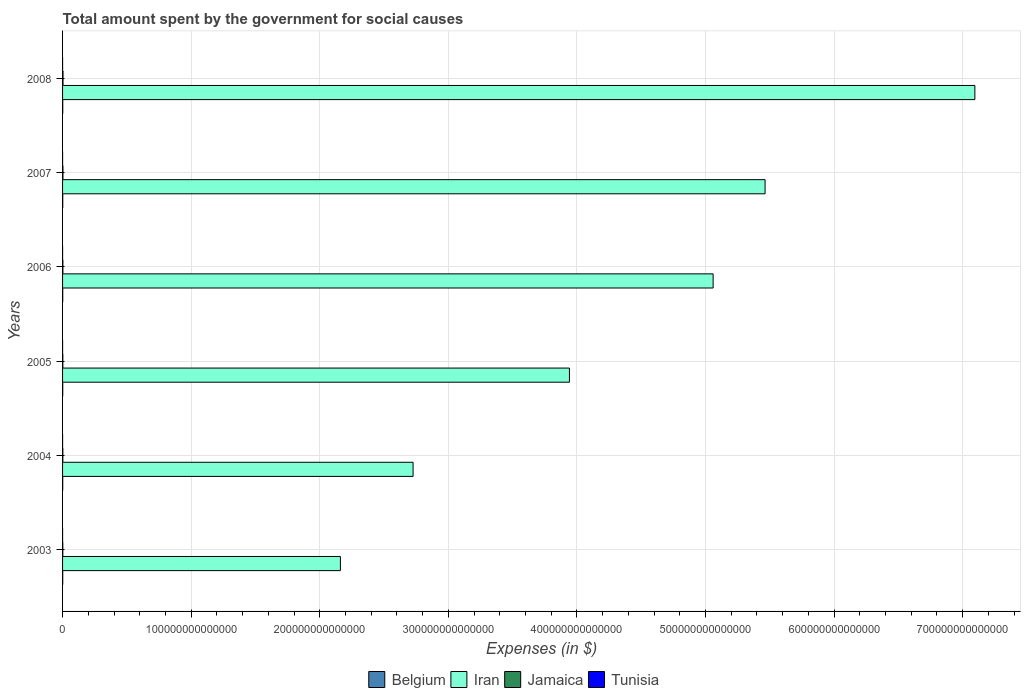How many different coloured bars are there?
Offer a very short reply. 4. How many groups of bars are there?
Your response must be concise. 6. Are the number of bars per tick equal to the number of legend labels?
Ensure brevity in your answer.  Yes. How many bars are there on the 1st tick from the top?
Ensure brevity in your answer.  4. How many bars are there on the 6th tick from the bottom?
Your response must be concise. 4. What is the label of the 6th group of bars from the top?
Offer a very short reply. 2003. What is the amount spent for social causes by the government in Belgium in 2004?
Make the answer very short. 1.21e+11. Across all years, what is the maximum amount spent for social causes by the government in Iran?
Give a very brief answer. 7.10e+14. Across all years, what is the minimum amount spent for social causes by the government in Tunisia?
Ensure brevity in your answer.  8.97e+09. In which year was the amount spent for social causes by the government in Jamaica maximum?
Your answer should be compact. 2008. What is the total amount spent for social causes by the government in Belgium in the graph?
Keep it short and to the point. 7.91e+11. What is the difference between the amount spent for social causes by the government in Tunisia in 2004 and that in 2006?
Give a very brief answer. -1.82e+09. What is the difference between the amount spent for social causes by the government in Jamaica in 2006 and the amount spent for social causes by the government in Tunisia in 2003?
Offer a very short reply. 2.46e+11. What is the average amount spent for social causes by the government in Belgium per year?
Make the answer very short. 1.32e+11. In the year 2004, what is the difference between the amount spent for social causes by the government in Belgium and amount spent for social causes by the government in Jamaica?
Make the answer very short. -9.24e+1. What is the ratio of the amount spent for social causes by the government in Iran in 2004 to that in 2006?
Your response must be concise. 0.54. What is the difference between the highest and the second highest amount spent for social causes by the government in Iran?
Your answer should be compact. 1.63e+14. What is the difference between the highest and the lowest amount spent for social causes by the government in Belgium?
Your answer should be compact. 2.75e+1. What does the 1st bar from the top in 2006 represents?
Your answer should be very brief. Tunisia. What does the 2nd bar from the bottom in 2006 represents?
Provide a short and direct response. Iran. What is the difference between two consecutive major ticks on the X-axis?
Provide a short and direct response. 1.00e+14. Does the graph contain any zero values?
Make the answer very short. No. Does the graph contain grids?
Ensure brevity in your answer.  Yes. What is the title of the graph?
Offer a very short reply. Total amount spent by the government for social causes. Does "Middle East & North Africa (all income levels)" appear as one of the legend labels in the graph?
Your answer should be compact. No. What is the label or title of the X-axis?
Your answer should be very brief. Expenses (in $). What is the label or title of the Y-axis?
Make the answer very short. Years. What is the Expenses (in $) of Belgium in 2003?
Your answer should be compact. 1.19e+11. What is the Expenses (in $) of Iran in 2003?
Provide a succinct answer. 2.16e+14. What is the Expenses (in $) in Jamaica in 2003?
Give a very brief answer. 1.87e+11. What is the Expenses (in $) in Tunisia in 2003?
Your answer should be very brief. 8.97e+09. What is the Expenses (in $) in Belgium in 2004?
Provide a short and direct response. 1.21e+11. What is the Expenses (in $) of Iran in 2004?
Keep it short and to the point. 2.73e+14. What is the Expenses (in $) of Jamaica in 2004?
Offer a terse response. 2.14e+11. What is the Expenses (in $) in Tunisia in 2004?
Make the answer very short. 1.00e+1. What is the Expenses (in $) of Belgium in 2005?
Your answer should be compact. 1.35e+11. What is the Expenses (in $) in Iran in 2005?
Give a very brief answer. 3.94e+14. What is the Expenses (in $) in Jamaica in 2005?
Provide a succinct answer. 2.15e+11. What is the Expenses (in $) of Tunisia in 2005?
Keep it short and to the point. 1.09e+1. What is the Expenses (in $) of Belgium in 2006?
Provide a short and direct response. 1.31e+11. What is the Expenses (in $) of Iran in 2006?
Make the answer very short. 5.06e+14. What is the Expenses (in $) of Jamaica in 2006?
Your answer should be very brief. 2.55e+11. What is the Expenses (in $) of Tunisia in 2006?
Your answer should be very brief. 1.18e+1. What is the Expenses (in $) in Belgium in 2007?
Ensure brevity in your answer.  1.38e+11. What is the Expenses (in $) in Iran in 2007?
Give a very brief answer. 5.46e+14. What is the Expenses (in $) of Jamaica in 2007?
Your response must be concise. 3.03e+11. What is the Expenses (in $) of Tunisia in 2007?
Provide a short and direct response. 1.31e+1. What is the Expenses (in $) of Belgium in 2008?
Provide a short and direct response. 1.47e+11. What is the Expenses (in $) in Iran in 2008?
Make the answer very short. 7.10e+14. What is the Expenses (in $) of Jamaica in 2008?
Make the answer very short. 3.55e+11. What is the Expenses (in $) of Tunisia in 2008?
Provide a short and direct response. 1.51e+1. Across all years, what is the maximum Expenses (in $) of Belgium?
Offer a terse response. 1.47e+11. Across all years, what is the maximum Expenses (in $) in Iran?
Make the answer very short. 7.10e+14. Across all years, what is the maximum Expenses (in $) of Jamaica?
Your answer should be compact. 3.55e+11. Across all years, what is the maximum Expenses (in $) of Tunisia?
Ensure brevity in your answer.  1.51e+1. Across all years, what is the minimum Expenses (in $) in Belgium?
Ensure brevity in your answer.  1.19e+11. Across all years, what is the minimum Expenses (in $) in Iran?
Your answer should be very brief. 2.16e+14. Across all years, what is the minimum Expenses (in $) of Jamaica?
Provide a short and direct response. 1.87e+11. Across all years, what is the minimum Expenses (in $) of Tunisia?
Make the answer very short. 8.97e+09. What is the total Expenses (in $) of Belgium in the graph?
Provide a short and direct response. 7.91e+11. What is the total Expenses (in $) of Iran in the graph?
Give a very brief answer. 2.64e+15. What is the total Expenses (in $) of Jamaica in the graph?
Your answer should be very brief. 1.53e+12. What is the total Expenses (in $) in Tunisia in the graph?
Your answer should be compact. 6.99e+1. What is the difference between the Expenses (in $) of Belgium in 2003 and that in 2004?
Keep it short and to the point. -1.83e+09. What is the difference between the Expenses (in $) in Iran in 2003 and that in 2004?
Your response must be concise. -5.65e+13. What is the difference between the Expenses (in $) of Jamaica in 2003 and that in 2004?
Your answer should be very brief. -2.65e+1. What is the difference between the Expenses (in $) in Tunisia in 2003 and that in 2004?
Make the answer very short. -1.04e+09. What is the difference between the Expenses (in $) in Belgium in 2003 and that in 2005?
Make the answer very short. -1.54e+1. What is the difference between the Expenses (in $) in Iran in 2003 and that in 2005?
Provide a short and direct response. -1.78e+14. What is the difference between the Expenses (in $) of Jamaica in 2003 and that in 2005?
Give a very brief answer. -2.84e+1. What is the difference between the Expenses (in $) of Tunisia in 2003 and that in 2005?
Your response must be concise. -1.98e+09. What is the difference between the Expenses (in $) of Belgium in 2003 and that in 2006?
Your response must be concise. -1.18e+1. What is the difference between the Expenses (in $) of Iran in 2003 and that in 2006?
Offer a very short reply. -2.90e+14. What is the difference between the Expenses (in $) of Jamaica in 2003 and that in 2006?
Keep it short and to the point. -6.77e+1. What is the difference between the Expenses (in $) in Tunisia in 2003 and that in 2006?
Your answer should be very brief. -2.85e+09. What is the difference between the Expenses (in $) of Belgium in 2003 and that in 2007?
Provide a short and direct response. -1.82e+1. What is the difference between the Expenses (in $) of Iran in 2003 and that in 2007?
Give a very brief answer. -3.30e+14. What is the difference between the Expenses (in $) in Jamaica in 2003 and that in 2007?
Provide a succinct answer. -1.16e+11. What is the difference between the Expenses (in $) in Tunisia in 2003 and that in 2007?
Provide a short and direct response. -4.08e+09. What is the difference between the Expenses (in $) of Belgium in 2003 and that in 2008?
Your answer should be compact. -2.75e+1. What is the difference between the Expenses (in $) in Iran in 2003 and that in 2008?
Offer a very short reply. -4.93e+14. What is the difference between the Expenses (in $) of Jamaica in 2003 and that in 2008?
Your answer should be compact. -1.68e+11. What is the difference between the Expenses (in $) in Tunisia in 2003 and that in 2008?
Give a very brief answer. -6.13e+09. What is the difference between the Expenses (in $) of Belgium in 2004 and that in 2005?
Keep it short and to the point. -1.36e+1. What is the difference between the Expenses (in $) of Iran in 2004 and that in 2005?
Offer a terse response. -1.22e+14. What is the difference between the Expenses (in $) of Jamaica in 2004 and that in 2005?
Make the answer very short. -1.88e+09. What is the difference between the Expenses (in $) in Tunisia in 2004 and that in 2005?
Provide a succinct answer. -9.39e+08. What is the difference between the Expenses (in $) of Belgium in 2004 and that in 2006?
Offer a very short reply. -9.96e+09. What is the difference between the Expenses (in $) in Iran in 2004 and that in 2006?
Ensure brevity in your answer.  -2.33e+14. What is the difference between the Expenses (in $) in Jamaica in 2004 and that in 2006?
Your answer should be compact. -4.11e+1. What is the difference between the Expenses (in $) of Tunisia in 2004 and that in 2006?
Ensure brevity in your answer.  -1.82e+09. What is the difference between the Expenses (in $) of Belgium in 2004 and that in 2007?
Your answer should be compact. -1.64e+1. What is the difference between the Expenses (in $) in Iran in 2004 and that in 2007?
Your answer should be compact. -2.74e+14. What is the difference between the Expenses (in $) in Jamaica in 2004 and that in 2007?
Provide a succinct answer. -8.98e+1. What is the difference between the Expenses (in $) in Tunisia in 2004 and that in 2007?
Your answer should be compact. -3.04e+09. What is the difference between the Expenses (in $) of Belgium in 2004 and that in 2008?
Provide a short and direct response. -2.57e+1. What is the difference between the Expenses (in $) of Iran in 2004 and that in 2008?
Give a very brief answer. -4.37e+14. What is the difference between the Expenses (in $) of Jamaica in 2004 and that in 2008?
Your response must be concise. -1.42e+11. What is the difference between the Expenses (in $) of Tunisia in 2004 and that in 2008?
Your answer should be compact. -5.09e+09. What is the difference between the Expenses (in $) of Belgium in 2005 and that in 2006?
Provide a succinct answer. 3.59e+09. What is the difference between the Expenses (in $) in Iran in 2005 and that in 2006?
Your answer should be very brief. -1.12e+14. What is the difference between the Expenses (in $) of Jamaica in 2005 and that in 2006?
Provide a short and direct response. -3.93e+1. What is the difference between the Expenses (in $) in Tunisia in 2005 and that in 2006?
Ensure brevity in your answer.  -8.79e+08. What is the difference between the Expenses (in $) in Belgium in 2005 and that in 2007?
Make the answer very short. -2.83e+09. What is the difference between the Expenses (in $) of Iran in 2005 and that in 2007?
Offer a terse response. -1.52e+14. What is the difference between the Expenses (in $) in Jamaica in 2005 and that in 2007?
Ensure brevity in your answer.  -8.79e+1. What is the difference between the Expenses (in $) of Tunisia in 2005 and that in 2007?
Your answer should be compact. -2.10e+09. What is the difference between the Expenses (in $) in Belgium in 2005 and that in 2008?
Provide a succinct answer. -1.21e+1. What is the difference between the Expenses (in $) in Iran in 2005 and that in 2008?
Your answer should be compact. -3.15e+14. What is the difference between the Expenses (in $) in Jamaica in 2005 and that in 2008?
Ensure brevity in your answer.  -1.40e+11. What is the difference between the Expenses (in $) of Tunisia in 2005 and that in 2008?
Ensure brevity in your answer.  -4.15e+09. What is the difference between the Expenses (in $) in Belgium in 2006 and that in 2007?
Give a very brief answer. -6.42e+09. What is the difference between the Expenses (in $) in Iran in 2006 and that in 2007?
Keep it short and to the point. -4.04e+13. What is the difference between the Expenses (in $) in Jamaica in 2006 and that in 2007?
Your answer should be very brief. -4.86e+1. What is the difference between the Expenses (in $) in Tunisia in 2006 and that in 2007?
Offer a terse response. -1.22e+09. What is the difference between the Expenses (in $) in Belgium in 2006 and that in 2008?
Give a very brief answer. -1.57e+1. What is the difference between the Expenses (in $) in Iran in 2006 and that in 2008?
Make the answer very short. -2.04e+14. What is the difference between the Expenses (in $) of Jamaica in 2006 and that in 2008?
Offer a very short reply. -1.01e+11. What is the difference between the Expenses (in $) of Tunisia in 2006 and that in 2008?
Make the answer very short. -3.27e+09. What is the difference between the Expenses (in $) in Belgium in 2007 and that in 2008?
Offer a very short reply. -9.32e+09. What is the difference between the Expenses (in $) of Iran in 2007 and that in 2008?
Provide a succinct answer. -1.63e+14. What is the difference between the Expenses (in $) in Jamaica in 2007 and that in 2008?
Provide a short and direct response. -5.21e+1. What is the difference between the Expenses (in $) in Tunisia in 2007 and that in 2008?
Your response must be concise. -2.05e+09. What is the difference between the Expenses (in $) of Belgium in 2003 and the Expenses (in $) of Iran in 2004?
Your response must be concise. -2.72e+14. What is the difference between the Expenses (in $) of Belgium in 2003 and the Expenses (in $) of Jamaica in 2004?
Give a very brief answer. -9.42e+1. What is the difference between the Expenses (in $) of Belgium in 2003 and the Expenses (in $) of Tunisia in 2004?
Make the answer very short. 1.09e+11. What is the difference between the Expenses (in $) in Iran in 2003 and the Expenses (in $) in Jamaica in 2004?
Your response must be concise. 2.16e+14. What is the difference between the Expenses (in $) of Iran in 2003 and the Expenses (in $) of Tunisia in 2004?
Give a very brief answer. 2.16e+14. What is the difference between the Expenses (in $) of Jamaica in 2003 and the Expenses (in $) of Tunisia in 2004?
Your answer should be very brief. 1.77e+11. What is the difference between the Expenses (in $) of Belgium in 2003 and the Expenses (in $) of Iran in 2005?
Your answer should be compact. -3.94e+14. What is the difference between the Expenses (in $) in Belgium in 2003 and the Expenses (in $) in Jamaica in 2005?
Offer a very short reply. -9.61e+1. What is the difference between the Expenses (in $) in Belgium in 2003 and the Expenses (in $) in Tunisia in 2005?
Offer a very short reply. 1.08e+11. What is the difference between the Expenses (in $) in Iran in 2003 and the Expenses (in $) in Jamaica in 2005?
Provide a succinct answer. 2.16e+14. What is the difference between the Expenses (in $) in Iran in 2003 and the Expenses (in $) in Tunisia in 2005?
Provide a succinct answer. 2.16e+14. What is the difference between the Expenses (in $) in Jamaica in 2003 and the Expenses (in $) in Tunisia in 2005?
Make the answer very short. 1.76e+11. What is the difference between the Expenses (in $) of Belgium in 2003 and the Expenses (in $) of Iran in 2006?
Offer a terse response. -5.06e+14. What is the difference between the Expenses (in $) of Belgium in 2003 and the Expenses (in $) of Jamaica in 2006?
Provide a succinct answer. -1.35e+11. What is the difference between the Expenses (in $) in Belgium in 2003 and the Expenses (in $) in Tunisia in 2006?
Ensure brevity in your answer.  1.07e+11. What is the difference between the Expenses (in $) of Iran in 2003 and the Expenses (in $) of Jamaica in 2006?
Offer a terse response. 2.16e+14. What is the difference between the Expenses (in $) of Iran in 2003 and the Expenses (in $) of Tunisia in 2006?
Offer a very short reply. 2.16e+14. What is the difference between the Expenses (in $) of Jamaica in 2003 and the Expenses (in $) of Tunisia in 2006?
Make the answer very short. 1.75e+11. What is the difference between the Expenses (in $) of Belgium in 2003 and the Expenses (in $) of Iran in 2007?
Offer a very short reply. -5.46e+14. What is the difference between the Expenses (in $) of Belgium in 2003 and the Expenses (in $) of Jamaica in 2007?
Give a very brief answer. -1.84e+11. What is the difference between the Expenses (in $) in Belgium in 2003 and the Expenses (in $) in Tunisia in 2007?
Ensure brevity in your answer.  1.06e+11. What is the difference between the Expenses (in $) in Iran in 2003 and the Expenses (in $) in Jamaica in 2007?
Make the answer very short. 2.16e+14. What is the difference between the Expenses (in $) of Iran in 2003 and the Expenses (in $) of Tunisia in 2007?
Make the answer very short. 2.16e+14. What is the difference between the Expenses (in $) of Jamaica in 2003 and the Expenses (in $) of Tunisia in 2007?
Your answer should be very brief. 1.74e+11. What is the difference between the Expenses (in $) in Belgium in 2003 and the Expenses (in $) in Iran in 2008?
Your response must be concise. -7.09e+14. What is the difference between the Expenses (in $) of Belgium in 2003 and the Expenses (in $) of Jamaica in 2008?
Offer a very short reply. -2.36e+11. What is the difference between the Expenses (in $) of Belgium in 2003 and the Expenses (in $) of Tunisia in 2008?
Provide a succinct answer. 1.04e+11. What is the difference between the Expenses (in $) in Iran in 2003 and the Expenses (in $) in Jamaica in 2008?
Your answer should be compact. 2.16e+14. What is the difference between the Expenses (in $) of Iran in 2003 and the Expenses (in $) of Tunisia in 2008?
Make the answer very short. 2.16e+14. What is the difference between the Expenses (in $) in Jamaica in 2003 and the Expenses (in $) in Tunisia in 2008?
Your response must be concise. 1.72e+11. What is the difference between the Expenses (in $) in Belgium in 2004 and the Expenses (in $) in Iran in 2005?
Offer a very short reply. -3.94e+14. What is the difference between the Expenses (in $) in Belgium in 2004 and the Expenses (in $) in Jamaica in 2005?
Make the answer very short. -9.43e+1. What is the difference between the Expenses (in $) of Belgium in 2004 and the Expenses (in $) of Tunisia in 2005?
Your answer should be compact. 1.10e+11. What is the difference between the Expenses (in $) of Iran in 2004 and the Expenses (in $) of Jamaica in 2005?
Give a very brief answer. 2.72e+14. What is the difference between the Expenses (in $) in Iran in 2004 and the Expenses (in $) in Tunisia in 2005?
Make the answer very short. 2.73e+14. What is the difference between the Expenses (in $) of Jamaica in 2004 and the Expenses (in $) of Tunisia in 2005?
Keep it short and to the point. 2.03e+11. What is the difference between the Expenses (in $) in Belgium in 2004 and the Expenses (in $) in Iran in 2006?
Offer a very short reply. -5.06e+14. What is the difference between the Expenses (in $) of Belgium in 2004 and the Expenses (in $) of Jamaica in 2006?
Keep it short and to the point. -1.34e+11. What is the difference between the Expenses (in $) of Belgium in 2004 and the Expenses (in $) of Tunisia in 2006?
Ensure brevity in your answer.  1.09e+11. What is the difference between the Expenses (in $) in Iran in 2004 and the Expenses (in $) in Jamaica in 2006?
Your answer should be compact. 2.72e+14. What is the difference between the Expenses (in $) of Iran in 2004 and the Expenses (in $) of Tunisia in 2006?
Provide a short and direct response. 2.73e+14. What is the difference between the Expenses (in $) in Jamaica in 2004 and the Expenses (in $) in Tunisia in 2006?
Offer a terse response. 2.02e+11. What is the difference between the Expenses (in $) in Belgium in 2004 and the Expenses (in $) in Iran in 2007?
Keep it short and to the point. -5.46e+14. What is the difference between the Expenses (in $) in Belgium in 2004 and the Expenses (in $) in Jamaica in 2007?
Provide a succinct answer. -1.82e+11. What is the difference between the Expenses (in $) of Belgium in 2004 and the Expenses (in $) of Tunisia in 2007?
Your answer should be compact. 1.08e+11. What is the difference between the Expenses (in $) of Iran in 2004 and the Expenses (in $) of Jamaica in 2007?
Give a very brief answer. 2.72e+14. What is the difference between the Expenses (in $) in Iran in 2004 and the Expenses (in $) in Tunisia in 2007?
Ensure brevity in your answer.  2.73e+14. What is the difference between the Expenses (in $) of Jamaica in 2004 and the Expenses (in $) of Tunisia in 2007?
Keep it short and to the point. 2.00e+11. What is the difference between the Expenses (in $) of Belgium in 2004 and the Expenses (in $) of Iran in 2008?
Offer a very short reply. -7.09e+14. What is the difference between the Expenses (in $) of Belgium in 2004 and the Expenses (in $) of Jamaica in 2008?
Ensure brevity in your answer.  -2.34e+11. What is the difference between the Expenses (in $) in Belgium in 2004 and the Expenses (in $) in Tunisia in 2008?
Your answer should be compact. 1.06e+11. What is the difference between the Expenses (in $) of Iran in 2004 and the Expenses (in $) of Jamaica in 2008?
Your answer should be compact. 2.72e+14. What is the difference between the Expenses (in $) of Iran in 2004 and the Expenses (in $) of Tunisia in 2008?
Ensure brevity in your answer.  2.73e+14. What is the difference between the Expenses (in $) in Jamaica in 2004 and the Expenses (in $) in Tunisia in 2008?
Keep it short and to the point. 1.98e+11. What is the difference between the Expenses (in $) of Belgium in 2005 and the Expenses (in $) of Iran in 2006?
Your response must be concise. -5.06e+14. What is the difference between the Expenses (in $) of Belgium in 2005 and the Expenses (in $) of Jamaica in 2006?
Your answer should be compact. -1.20e+11. What is the difference between the Expenses (in $) in Belgium in 2005 and the Expenses (in $) in Tunisia in 2006?
Keep it short and to the point. 1.23e+11. What is the difference between the Expenses (in $) of Iran in 2005 and the Expenses (in $) of Jamaica in 2006?
Provide a succinct answer. 3.94e+14. What is the difference between the Expenses (in $) in Iran in 2005 and the Expenses (in $) in Tunisia in 2006?
Offer a very short reply. 3.94e+14. What is the difference between the Expenses (in $) in Jamaica in 2005 and the Expenses (in $) in Tunisia in 2006?
Your answer should be very brief. 2.04e+11. What is the difference between the Expenses (in $) of Belgium in 2005 and the Expenses (in $) of Iran in 2007?
Offer a terse response. -5.46e+14. What is the difference between the Expenses (in $) of Belgium in 2005 and the Expenses (in $) of Jamaica in 2007?
Make the answer very short. -1.69e+11. What is the difference between the Expenses (in $) in Belgium in 2005 and the Expenses (in $) in Tunisia in 2007?
Provide a short and direct response. 1.22e+11. What is the difference between the Expenses (in $) in Iran in 2005 and the Expenses (in $) in Jamaica in 2007?
Make the answer very short. 3.94e+14. What is the difference between the Expenses (in $) of Iran in 2005 and the Expenses (in $) of Tunisia in 2007?
Make the answer very short. 3.94e+14. What is the difference between the Expenses (in $) of Jamaica in 2005 and the Expenses (in $) of Tunisia in 2007?
Keep it short and to the point. 2.02e+11. What is the difference between the Expenses (in $) of Belgium in 2005 and the Expenses (in $) of Iran in 2008?
Make the answer very short. -7.09e+14. What is the difference between the Expenses (in $) in Belgium in 2005 and the Expenses (in $) in Jamaica in 2008?
Ensure brevity in your answer.  -2.21e+11. What is the difference between the Expenses (in $) of Belgium in 2005 and the Expenses (in $) of Tunisia in 2008?
Offer a terse response. 1.20e+11. What is the difference between the Expenses (in $) of Iran in 2005 and the Expenses (in $) of Jamaica in 2008?
Offer a very short reply. 3.94e+14. What is the difference between the Expenses (in $) in Iran in 2005 and the Expenses (in $) in Tunisia in 2008?
Provide a short and direct response. 3.94e+14. What is the difference between the Expenses (in $) of Jamaica in 2005 and the Expenses (in $) of Tunisia in 2008?
Your answer should be very brief. 2.00e+11. What is the difference between the Expenses (in $) in Belgium in 2006 and the Expenses (in $) in Iran in 2007?
Make the answer very short. -5.46e+14. What is the difference between the Expenses (in $) in Belgium in 2006 and the Expenses (in $) in Jamaica in 2007?
Your answer should be very brief. -1.72e+11. What is the difference between the Expenses (in $) of Belgium in 2006 and the Expenses (in $) of Tunisia in 2007?
Ensure brevity in your answer.  1.18e+11. What is the difference between the Expenses (in $) of Iran in 2006 and the Expenses (in $) of Jamaica in 2007?
Ensure brevity in your answer.  5.06e+14. What is the difference between the Expenses (in $) in Iran in 2006 and the Expenses (in $) in Tunisia in 2007?
Ensure brevity in your answer.  5.06e+14. What is the difference between the Expenses (in $) in Jamaica in 2006 and the Expenses (in $) in Tunisia in 2007?
Your answer should be very brief. 2.42e+11. What is the difference between the Expenses (in $) of Belgium in 2006 and the Expenses (in $) of Iran in 2008?
Give a very brief answer. -7.09e+14. What is the difference between the Expenses (in $) of Belgium in 2006 and the Expenses (in $) of Jamaica in 2008?
Provide a short and direct response. -2.24e+11. What is the difference between the Expenses (in $) in Belgium in 2006 and the Expenses (in $) in Tunisia in 2008?
Provide a short and direct response. 1.16e+11. What is the difference between the Expenses (in $) of Iran in 2006 and the Expenses (in $) of Jamaica in 2008?
Make the answer very short. 5.06e+14. What is the difference between the Expenses (in $) in Iran in 2006 and the Expenses (in $) in Tunisia in 2008?
Your answer should be compact. 5.06e+14. What is the difference between the Expenses (in $) of Jamaica in 2006 and the Expenses (in $) of Tunisia in 2008?
Make the answer very short. 2.40e+11. What is the difference between the Expenses (in $) in Belgium in 2007 and the Expenses (in $) in Iran in 2008?
Make the answer very short. -7.09e+14. What is the difference between the Expenses (in $) in Belgium in 2007 and the Expenses (in $) in Jamaica in 2008?
Provide a succinct answer. -2.18e+11. What is the difference between the Expenses (in $) in Belgium in 2007 and the Expenses (in $) in Tunisia in 2008?
Your response must be concise. 1.22e+11. What is the difference between the Expenses (in $) in Iran in 2007 and the Expenses (in $) in Jamaica in 2008?
Offer a very short reply. 5.46e+14. What is the difference between the Expenses (in $) of Iran in 2007 and the Expenses (in $) of Tunisia in 2008?
Offer a very short reply. 5.46e+14. What is the difference between the Expenses (in $) of Jamaica in 2007 and the Expenses (in $) of Tunisia in 2008?
Your answer should be very brief. 2.88e+11. What is the average Expenses (in $) in Belgium per year?
Your answer should be very brief. 1.32e+11. What is the average Expenses (in $) of Iran per year?
Provide a succinct answer. 4.41e+14. What is the average Expenses (in $) of Jamaica per year?
Ensure brevity in your answer.  2.55e+11. What is the average Expenses (in $) in Tunisia per year?
Offer a very short reply. 1.17e+1. In the year 2003, what is the difference between the Expenses (in $) in Belgium and Expenses (in $) in Iran?
Your response must be concise. -2.16e+14. In the year 2003, what is the difference between the Expenses (in $) of Belgium and Expenses (in $) of Jamaica?
Offer a very short reply. -6.77e+1. In the year 2003, what is the difference between the Expenses (in $) in Belgium and Expenses (in $) in Tunisia?
Provide a succinct answer. 1.10e+11. In the year 2003, what is the difference between the Expenses (in $) of Iran and Expenses (in $) of Jamaica?
Offer a terse response. 2.16e+14. In the year 2003, what is the difference between the Expenses (in $) in Iran and Expenses (in $) in Tunisia?
Make the answer very short. 2.16e+14. In the year 2003, what is the difference between the Expenses (in $) in Jamaica and Expenses (in $) in Tunisia?
Keep it short and to the point. 1.78e+11. In the year 2004, what is the difference between the Expenses (in $) in Belgium and Expenses (in $) in Iran?
Offer a terse response. -2.72e+14. In the year 2004, what is the difference between the Expenses (in $) in Belgium and Expenses (in $) in Jamaica?
Keep it short and to the point. -9.24e+1. In the year 2004, what is the difference between the Expenses (in $) in Belgium and Expenses (in $) in Tunisia?
Provide a succinct answer. 1.11e+11. In the year 2004, what is the difference between the Expenses (in $) of Iran and Expenses (in $) of Jamaica?
Keep it short and to the point. 2.72e+14. In the year 2004, what is the difference between the Expenses (in $) in Iran and Expenses (in $) in Tunisia?
Provide a succinct answer. 2.73e+14. In the year 2004, what is the difference between the Expenses (in $) of Jamaica and Expenses (in $) of Tunisia?
Offer a terse response. 2.04e+11. In the year 2005, what is the difference between the Expenses (in $) in Belgium and Expenses (in $) in Iran?
Make the answer very short. -3.94e+14. In the year 2005, what is the difference between the Expenses (in $) of Belgium and Expenses (in $) of Jamaica?
Provide a short and direct response. -8.07e+1. In the year 2005, what is the difference between the Expenses (in $) of Belgium and Expenses (in $) of Tunisia?
Provide a short and direct response. 1.24e+11. In the year 2005, what is the difference between the Expenses (in $) of Iran and Expenses (in $) of Jamaica?
Provide a succinct answer. 3.94e+14. In the year 2005, what is the difference between the Expenses (in $) of Iran and Expenses (in $) of Tunisia?
Your answer should be very brief. 3.94e+14. In the year 2005, what is the difference between the Expenses (in $) of Jamaica and Expenses (in $) of Tunisia?
Provide a succinct answer. 2.04e+11. In the year 2006, what is the difference between the Expenses (in $) of Belgium and Expenses (in $) of Iran?
Make the answer very short. -5.06e+14. In the year 2006, what is the difference between the Expenses (in $) of Belgium and Expenses (in $) of Jamaica?
Give a very brief answer. -1.24e+11. In the year 2006, what is the difference between the Expenses (in $) of Belgium and Expenses (in $) of Tunisia?
Your answer should be very brief. 1.19e+11. In the year 2006, what is the difference between the Expenses (in $) of Iran and Expenses (in $) of Jamaica?
Provide a short and direct response. 5.06e+14. In the year 2006, what is the difference between the Expenses (in $) in Iran and Expenses (in $) in Tunisia?
Your answer should be very brief. 5.06e+14. In the year 2006, what is the difference between the Expenses (in $) in Jamaica and Expenses (in $) in Tunisia?
Keep it short and to the point. 2.43e+11. In the year 2007, what is the difference between the Expenses (in $) in Belgium and Expenses (in $) in Iran?
Offer a very short reply. -5.46e+14. In the year 2007, what is the difference between the Expenses (in $) in Belgium and Expenses (in $) in Jamaica?
Offer a terse response. -1.66e+11. In the year 2007, what is the difference between the Expenses (in $) in Belgium and Expenses (in $) in Tunisia?
Make the answer very short. 1.24e+11. In the year 2007, what is the difference between the Expenses (in $) in Iran and Expenses (in $) in Jamaica?
Your response must be concise. 5.46e+14. In the year 2007, what is the difference between the Expenses (in $) in Iran and Expenses (in $) in Tunisia?
Keep it short and to the point. 5.46e+14. In the year 2007, what is the difference between the Expenses (in $) in Jamaica and Expenses (in $) in Tunisia?
Provide a succinct answer. 2.90e+11. In the year 2008, what is the difference between the Expenses (in $) in Belgium and Expenses (in $) in Iran?
Offer a very short reply. -7.09e+14. In the year 2008, what is the difference between the Expenses (in $) of Belgium and Expenses (in $) of Jamaica?
Your answer should be compact. -2.09e+11. In the year 2008, what is the difference between the Expenses (in $) of Belgium and Expenses (in $) of Tunisia?
Your answer should be compact. 1.32e+11. In the year 2008, what is the difference between the Expenses (in $) of Iran and Expenses (in $) of Jamaica?
Your answer should be very brief. 7.09e+14. In the year 2008, what is the difference between the Expenses (in $) of Iran and Expenses (in $) of Tunisia?
Provide a short and direct response. 7.10e+14. In the year 2008, what is the difference between the Expenses (in $) of Jamaica and Expenses (in $) of Tunisia?
Offer a terse response. 3.40e+11. What is the ratio of the Expenses (in $) in Belgium in 2003 to that in 2004?
Make the answer very short. 0.98. What is the ratio of the Expenses (in $) in Iran in 2003 to that in 2004?
Give a very brief answer. 0.79. What is the ratio of the Expenses (in $) in Jamaica in 2003 to that in 2004?
Provide a succinct answer. 0.88. What is the ratio of the Expenses (in $) in Tunisia in 2003 to that in 2004?
Offer a very short reply. 0.9. What is the ratio of the Expenses (in $) of Belgium in 2003 to that in 2005?
Your response must be concise. 0.89. What is the ratio of the Expenses (in $) in Iran in 2003 to that in 2005?
Offer a very short reply. 0.55. What is the ratio of the Expenses (in $) in Jamaica in 2003 to that in 2005?
Give a very brief answer. 0.87. What is the ratio of the Expenses (in $) in Tunisia in 2003 to that in 2005?
Your answer should be compact. 0.82. What is the ratio of the Expenses (in $) in Belgium in 2003 to that in 2006?
Your answer should be very brief. 0.91. What is the ratio of the Expenses (in $) of Iran in 2003 to that in 2006?
Keep it short and to the point. 0.43. What is the ratio of the Expenses (in $) of Jamaica in 2003 to that in 2006?
Make the answer very short. 0.73. What is the ratio of the Expenses (in $) of Tunisia in 2003 to that in 2006?
Ensure brevity in your answer.  0.76. What is the ratio of the Expenses (in $) in Belgium in 2003 to that in 2007?
Make the answer very short. 0.87. What is the ratio of the Expenses (in $) of Iran in 2003 to that in 2007?
Your answer should be very brief. 0.4. What is the ratio of the Expenses (in $) in Jamaica in 2003 to that in 2007?
Your answer should be very brief. 0.62. What is the ratio of the Expenses (in $) of Tunisia in 2003 to that in 2007?
Give a very brief answer. 0.69. What is the ratio of the Expenses (in $) in Belgium in 2003 to that in 2008?
Your answer should be very brief. 0.81. What is the ratio of the Expenses (in $) in Iran in 2003 to that in 2008?
Your answer should be very brief. 0.3. What is the ratio of the Expenses (in $) in Jamaica in 2003 to that in 2008?
Ensure brevity in your answer.  0.53. What is the ratio of the Expenses (in $) in Tunisia in 2003 to that in 2008?
Your answer should be very brief. 0.59. What is the ratio of the Expenses (in $) of Belgium in 2004 to that in 2005?
Your answer should be very brief. 0.9. What is the ratio of the Expenses (in $) of Iran in 2004 to that in 2005?
Give a very brief answer. 0.69. What is the ratio of the Expenses (in $) in Jamaica in 2004 to that in 2005?
Offer a very short reply. 0.99. What is the ratio of the Expenses (in $) in Tunisia in 2004 to that in 2005?
Ensure brevity in your answer.  0.91. What is the ratio of the Expenses (in $) of Belgium in 2004 to that in 2006?
Offer a very short reply. 0.92. What is the ratio of the Expenses (in $) in Iran in 2004 to that in 2006?
Offer a very short reply. 0.54. What is the ratio of the Expenses (in $) of Jamaica in 2004 to that in 2006?
Ensure brevity in your answer.  0.84. What is the ratio of the Expenses (in $) of Tunisia in 2004 to that in 2006?
Your response must be concise. 0.85. What is the ratio of the Expenses (in $) of Belgium in 2004 to that in 2007?
Give a very brief answer. 0.88. What is the ratio of the Expenses (in $) of Iran in 2004 to that in 2007?
Provide a short and direct response. 0.5. What is the ratio of the Expenses (in $) in Jamaica in 2004 to that in 2007?
Ensure brevity in your answer.  0.7. What is the ratio of the Expenses (in $) in Tunisia in 2004 to that in 2007?
Your answer should be compact. 0.77. What is the ratio of the Expenses (in $) of Belgium in 2004 to that in 2008?
Your answer should be compact. 0.82. What is the ratio of the Expenses (in $) in Iran in 2004 to that in 2008?
Provide a succinct answer. 0.38. What is the ratio of the Expenses (in $) of Jamaica in 2004 to that in 2008?
Your answer should be very brief. 0.6. What is the ratio of the Expenses (in $) in Tunisia in 2004 to that in 2008?
Give a very brief answer. 0.66. What is the ratio of the Expenses (in $) in Belgium in 2005 to that in 2006?
Your answer should be very brief. 1.03. What is the ratio of the Expenses (in $) of Iran in 2005 to that in 2006?
Your response must be concise. 0.78. What is the ratio of the Expenses (in $) in Jamaica in 2005 to that in 2006?
Your answer should be compact. 0.85. What is the ratio of the Expenses (in $) of Tunisia in 2005 to that in 2006?
Give a very brief answer. 0.93. What is the ratio of the Expenses (in $) in Belgium in 2005 to that in 2007?
Give a very brief answer. 0.98. What is the ratio of the Expenses (in $) in Iran in 2005 to that in 2007?
Give a very brief answer. 0.72. What is the ratio of the Expenses (in $) of Jamaica in 2005 to that in 2007?
Provide a succinct answer. 0.71. What is the ratio of the Expenses (in $) in Tunisia in 2005 to that in 2007?
Offer a terse response. 0.84. What is the ratio of the Expenses (in $) in Belgium in 2005 to that in 2008?
Provide a short and direct response. 0.92. What is the ratio of the Expenses (in $) in Iran in 2005 to that in 2008?
Your answer should be compact. 0.56. What is the ratio of the Expenses (in $) in Jamaica in 2005 to that in 2008?
Offer a terse response. 0.61. What is the ratio of the Expenses (in $) of Tunisia in 2005 to that in 2008?
Ensure brevity in your answer.  0.72. What is the ratio of the Expenses (in $) in Belgium in 2006 to that in 2007?
Make the answer very short. 0.95. What is the ratio of the Expenses (in $) in Iran in 2006 to that in 2007?
Provide a short and direct response. 0.93. What is the ratio of the Expenses (in $) in Jamaica in 2006 to that in 2007?
Your answer should be compact. 0.84. What is the ratio of the Expenses (in $) in Tunisia in 2006 to that in 2007?
Provide a short and direct response. 0.91. What is the ratio of the Expenses (in $) in Belgium in 2006 to that in 2008?
Offer a very short reply. 0.89. What is the ratio of the Expenses (in $) in Iran in 2006 to that in 2008?
Offer a very short reply. 0.71. What is the ratio of the Expenses (in $) in Jamaica in 2006 to that in 2008?
Provide a succinct answer. 0.72. What is the ratio of the Expenses (in $) of Tunisia in 2006 to that in 2008?
Your answer should be compact. 0.78. What is the ratio of the Expenses (in $) in Belgium in 2007 to that in 2008?
Offer a terse response. 0.94. What is the ratio of the Expenses (in $) in Iran in 2007 to that in 2008?
Ensure brevity in your answer.  0.77. What is the ratio of the Expenses (in $) of Jamaica in 2007 to that in 2008?
Keep it short and to the point. 0.85. What is the ratio of the Expenses (in $) in Tunisia in 2007 to that in 2008?
Provide a succinct answer. 0.86. What is the difference between the highest and the second highest Expenses (in $) of Belgium?
Your answer should be compact. 9.32e+09. What is the difference between the highest and the second highest Expenses (in $) in Iran?
Provide a short and direct response. 1.63e+14. What is the difference between the highest and the second highest Expenses (in $) in Jamaica?
Provide a succinct answer. 5.21e+1. What is the difference between the highest and the second highest Expenses (in $) in Tunisia?
Offer a very short reply. 2.05e+09. What is the difference between the highest and the lowest Expenses (in $) of Belgium?
Your answer should be compact. 2.75e+1. What is the difference between the highest and the lowest Expenses (in $) of Iran?
Provide a short and direct response. 4.93e+14. What is the difference between the highest and the lowest Expenses (in $) of Jamaica?
Your answer should be compact. 1.68e+11. What is the difference between the highest and the lowest Expenses (in $) of Tunisia?
Provide a short and direct response. 6.13e+09. 